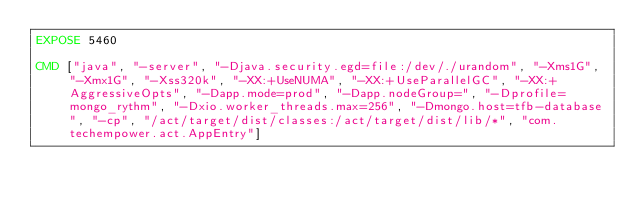Convert code to text. <code><loc_0><loc_0><loc_500><loc_500><_Dockerfile_>EXPOSE 5460

CMD ["java", "-server", "-Djava.security.egd=file:/dev/./urandom", "-Xms1G", "-Xmx1G", "-Xss320k", "-XX:+UseNUMA", "-XX:+UseParallelGC", "-XX:+AggressiveOpts", "-Dapp.mode=prod", "-Dapp.nodeGroup=", "-Dprofile=mongo_rythm", "-Dxio.worker_threads.max=256", "-Dmongo.host=tfb-database", "-cp", "/act/target/dist/classes:/act/target/dist/lib/*", "com.techempower.act.AppEntry"]
</code> 